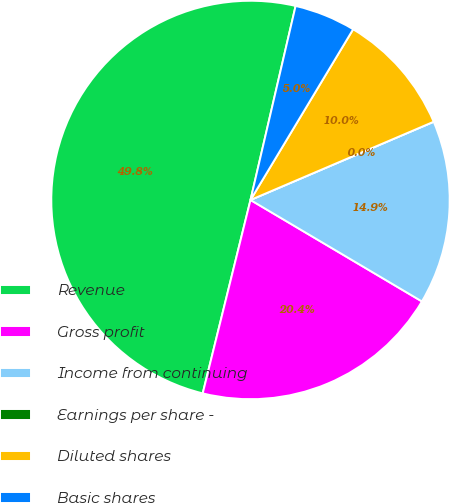Convert chart to OTSL. <chart><loc_0><loc_0><loc_500><loc_500><pie_chart><fcel>Revenue<fcel>Gross profit<fcel>Income from continuing<fcel>Earnings per share -<fcel>Diluted shares<fcel>Basic shares<nl><fcel>49.78%<fcel>20.35%<fcel>14.93%<fcel>0.0%<fcel>9.96%<fcel>4.98%<nl></chart> 